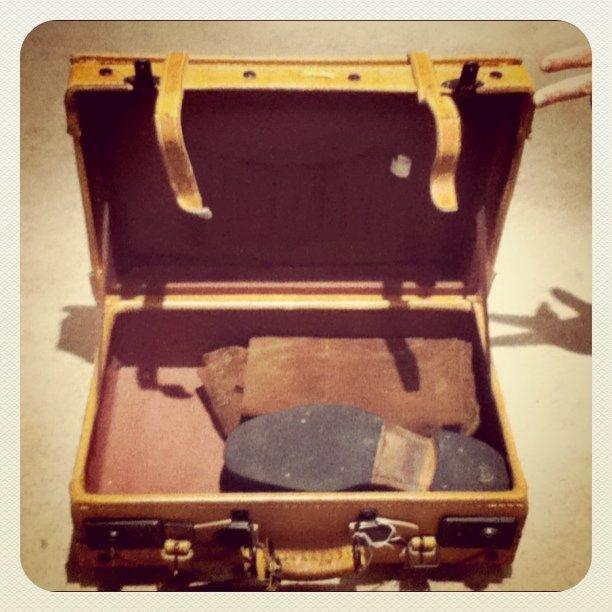Do you see shoes in the suitcase?
Be succinct. Yes. Is this a secure suitcase?
Answer briefly. No. How many fingers is the figure holding up next to the suitcase?
Be succinct. 2. 